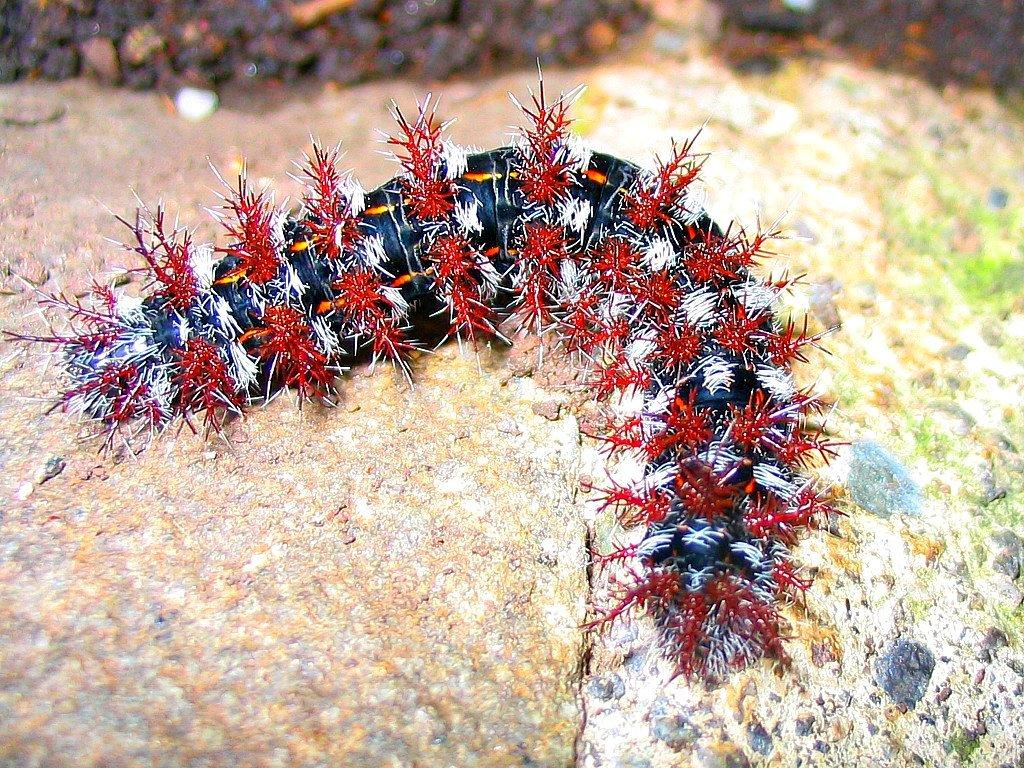What is the main subject in the foreground of the image? There is a caterpillar in the foreground of the image. How many kittens are reading books in the image? There are no kittens or books present in the image; it features a caterpillar in the foreground. 